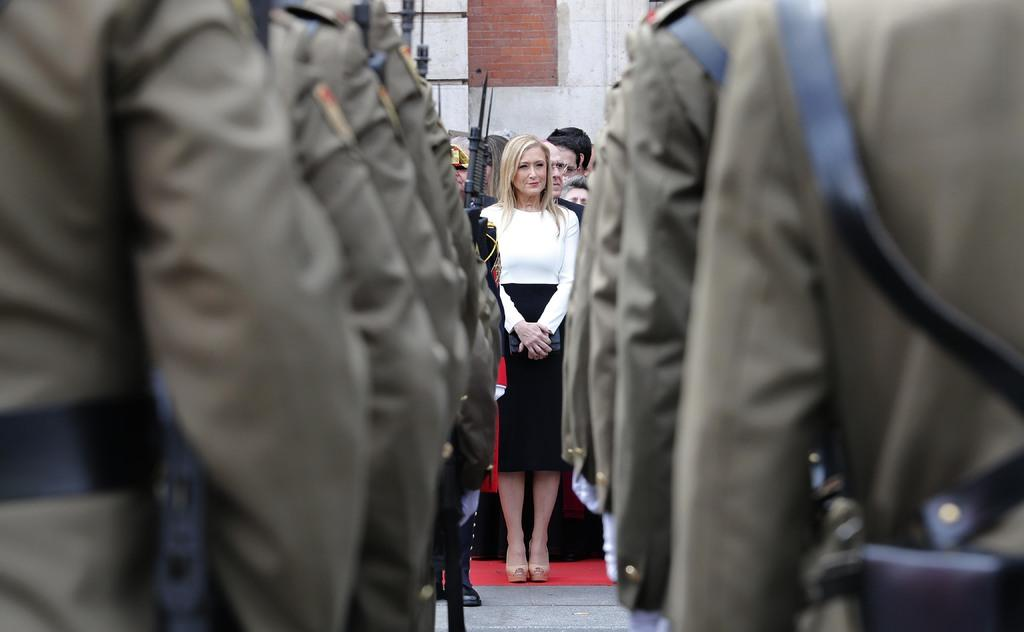What is happening in the image? There are people standing in the image. What can be seen in the background of the image? There is a wall visible in the background of the image. What type of wax is being used by the people in the image? There is no wax present in the image, as it only features people standing and a wall in the background. 